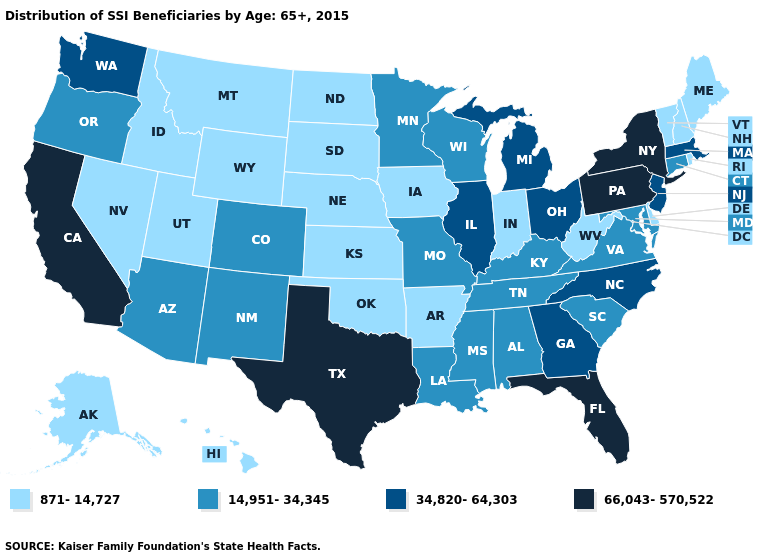Does Nevada have the lowest value in the West?
Be succinct. Yes. Does Texas have the lowest value in the USA?
Quick response, please. No. Does Indiana have the lowest value in the MidWest?
Answer briefly. Yes. What is the value of Arkansas?
Short answer required. 871-14,727. Is the legend a continuous bar?
Give a very brief answer. No. Is the legend a continuous bar?
Write a very short answer. No. How many symbols are there in the legend?
Give a very brief answer. 4. Which states have the lowest value in the South?
Be succinct. Arkansas, Delaware, Oklahoma, West Virginia. Does Connecticut have a higher value than Oklahoma?
Quick response, please. Yes. What is the value of California?
Answer briefly. 66,043-570,522. Which states hav the highest value in the West?
Quick response, please. California. What is the value of Georgia?
Concise answer only. 34,820-64,303. Name the states that have a value in the range 871-14,727?
Be succinct. Alaska, Arkansas, Delaware, Hawaii, Idaho, Indiana, Iowa, Kansas, Maine, Montana, Nebraska, Nevada, New Hampshire, North Dakota, Oklahoma, Rhode Island, South Dakota, Utah, Vermont, West Virginia, Wyoming. Among the states that border Georgia , does South Carolina have the lowest value?
Concise answer only. Yes. Among the states that border Texas , which have the highest value?
Write a very short answer. Louisiana, New Mexico. 